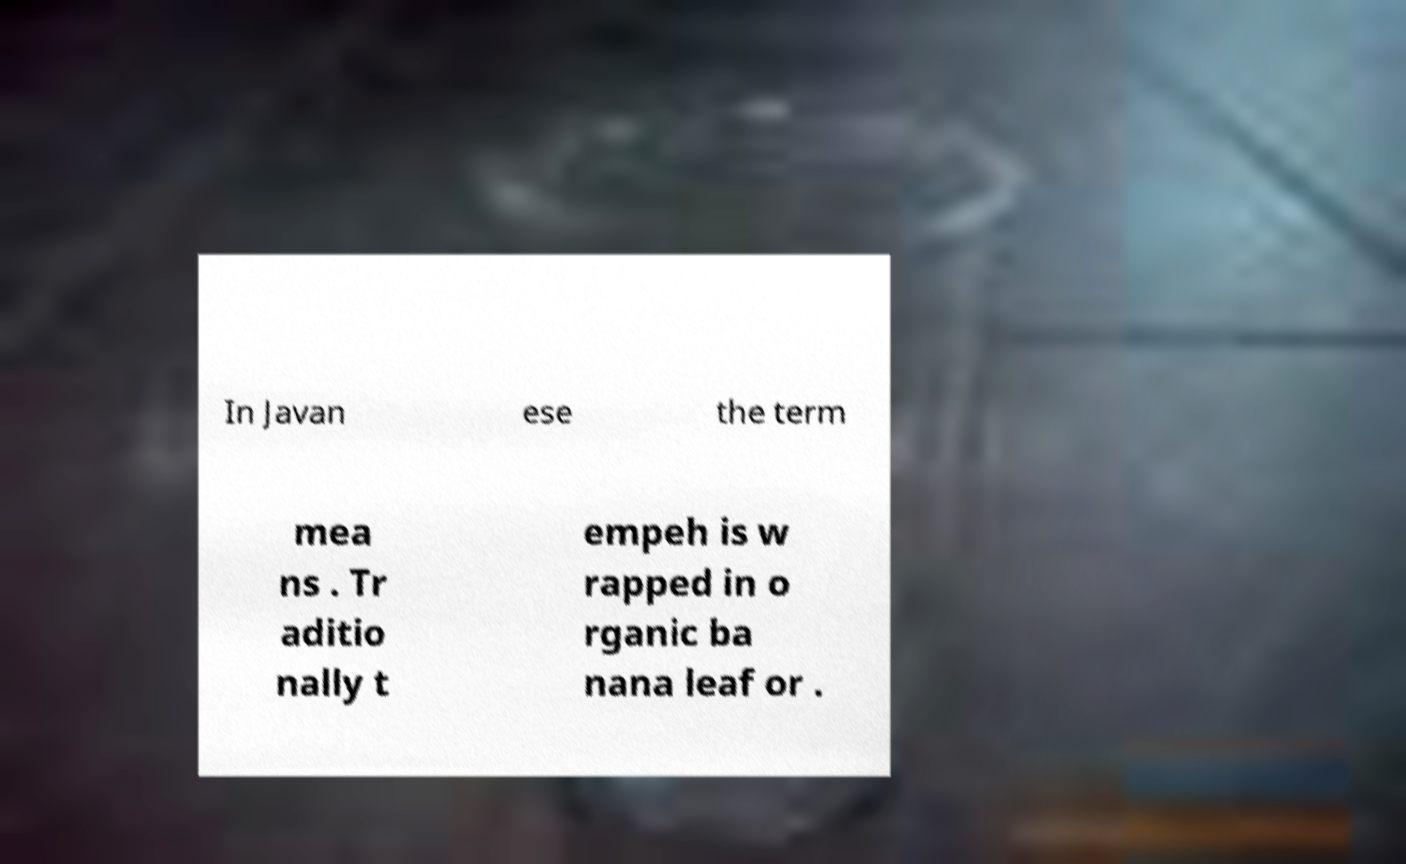Please identify and transcribe the text found in this image. In Javan ese the term mea ns . Tr aditio nally t empeh is w rapped in o rganic ba nana leaf or . 